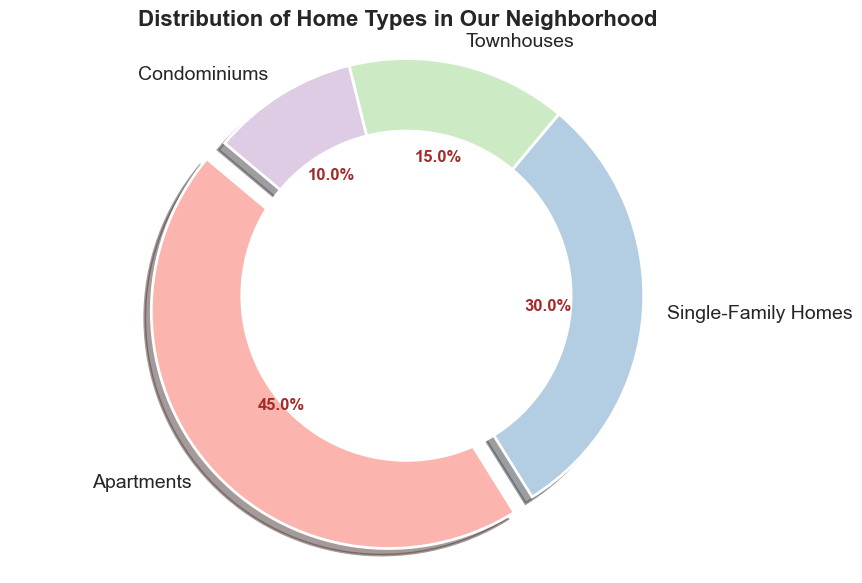What is the percentage of Single-Family Homes in the neighborhood? The pie chart indicates the percentage directly on the slice labeled "Single-Family Homes". The number given on the slice is 30.8%.
Answer: 30.8% Which home type has the largest representation in the neighborhood? By looking at the pie chart, the slice labeled "Apartments" is the largest and visually stands out as the biggest section, accounting for the highest percentage.
Answer: Apartments Add the percentages of Townhouses and Condominiums. What is the result? The pie chart shows that Townhouses account for 15.4% and Condominiums for 10.2%. Adding these percentages: 15.4% + 10.2% = 25.6%.
Answer: 25.6% How does the number of Apartments compare to the number of Single-Family Homes? The figure shows Apartments make up 45 units and Single-Family Homes account for 30 units. Comparatively, there are more Apartments than Single-Family Homes.
Answer: More Apartments Which section has the smallest percentage share in the pie chart? The smallest slice on the pie chart, as per the visual size and the percentage displayed, is labeled "Condominiums". It has 10.2%.
Answer: Condominiums If we added one more Townhouse to the count, what would the new percentage be? Original count of Townhouses: 15. New count: 15 + 1 = 16. Recalculate the percentage: (16 / (45 + 30 + 15 + 10 + 1)) * 100 ≈ 16 / 101 * 100 ≈ 15.8%.
Answer: 15.8% What is the total number of homes represented in this pie chart? The data table provides counts: Apartments (45), Single-Family Homes (30), Townhouses (15), and Condominiums (10). Summing these counts: 45 + 30 + 15 + 10 = 100.
Answer: 100 How many more Apartments are there compared to Condominiums? The figure shows Apartments count is 45 and Condominiums count is 10. The difference is calculated as 45 - 10 = 35.
Answer: 35 Compare the visual sizes of the slices for Townhouses and Single-Family Homes. Which is larger? The slice labeled "Single-Family Homes" is visually larger than the slice labeled "Townhouses", indicating a higher count and percentage.
Answer: Single-Family Homes Calculate the combined percentage of the three smallest home types. The smallest slices in the pie chart are for Single-Family Homes (30.8%), Townhouses (15.4%), and Condominiums (10.2%). Adding these percentages: 30.8% + 15.4% + 10.2% = 56.4%.
Answer: 56.4% 